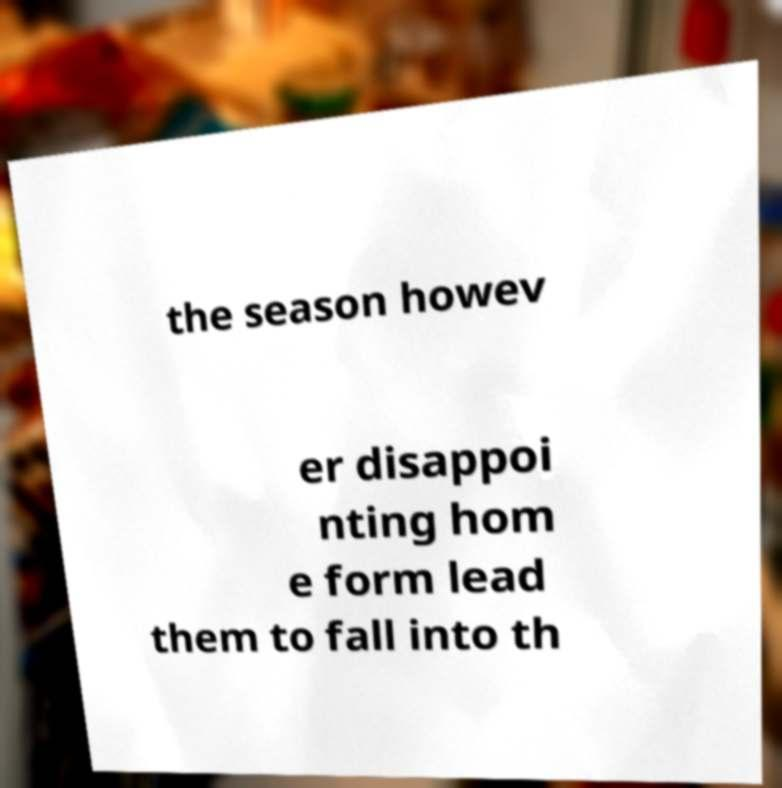Could you assist in decoding the text presented in this image and type it out clearly? the season howev er disappoi nting hom e form lead them to fall into th 